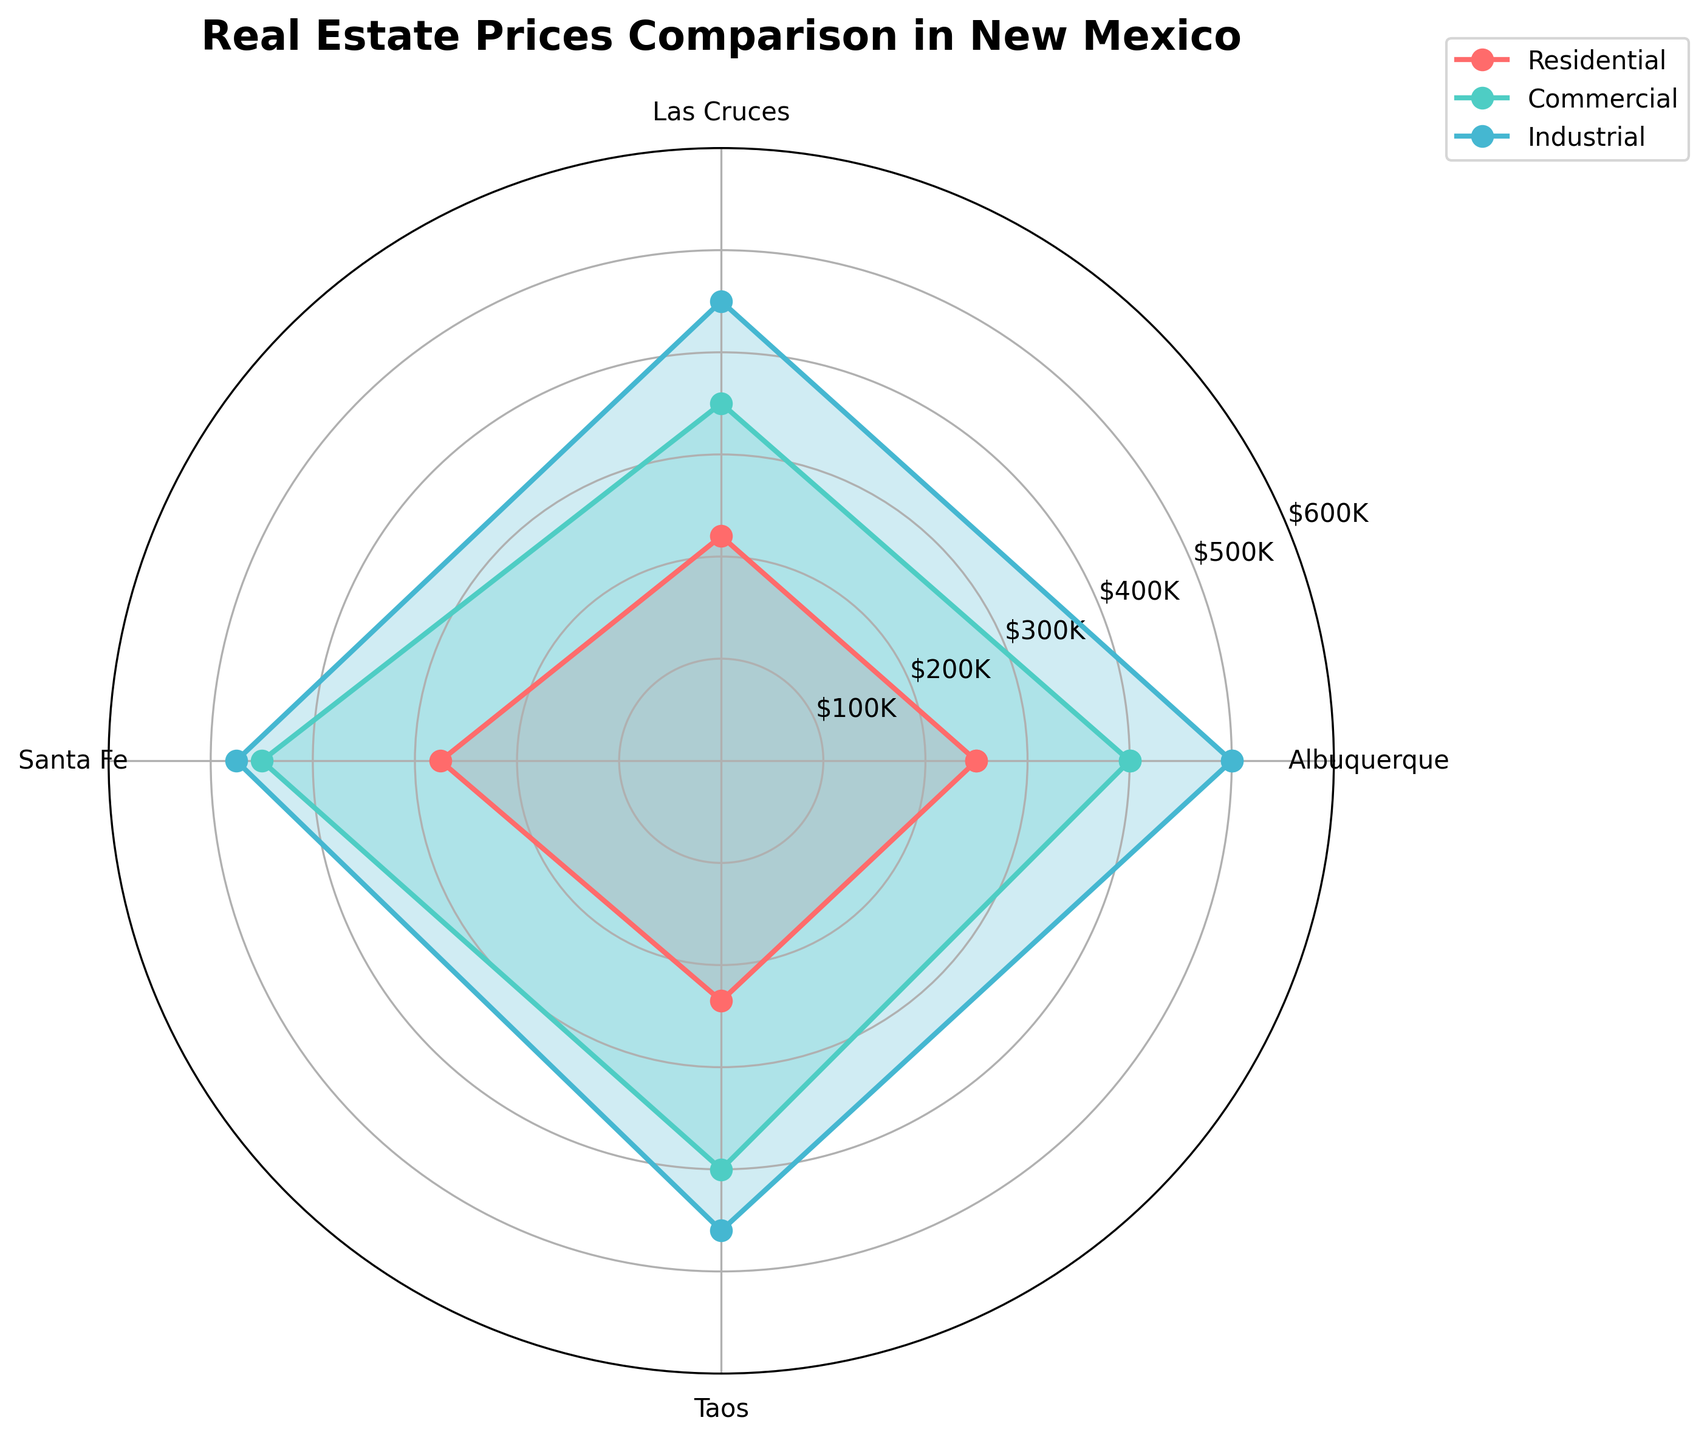What's the title of the chart? The title is displayed at the top of the chart.
Answer: Real Estate Prices Comparison in New Mexico What property type has the highest price in Taos? We look at the Taos value for each property type. Industrial has the highest value.
Answer: Industrial Which property type shows the most significant price difference between Albuquerque and Santa Fe? Calculate the differences: Residential (25,000), Commercial (50,000), Industrial (25,000). The largest difference is for Commercial.
Answer: Commercial What is the average price of commercial properties across all cities? Sum the commercial property prices (400,000 + 350,000 + 450,000 + 400,000) and divide by 4.
Answer: 400,000 Between residential and industrial properties, which type is generally more expensive in all cities combined? Compare the sum of residential prices to the sum of industrial prices: Residential (250,000 + 220,000 + 275,000 + 235,000) & Industrial (500,000 + 450,000 + 475,000 + 460,000). Industrial is higher in all locations.
Answer: Industrial What is the range of residential property prices in the cities shown? Subtract the lowest residential price (220,000) from the highest (275,000).
Answer: 55,000 How does the price trend of commercial properties vary across the cities? By evaluating each city's commercial property prices, we see they are generally highest in Santa Fe, lower in Las Cruces, and lower in Albuquerque and Taos.
Answer: Highest in Santa Fe, lower in Las Cruces, then Albuquerque and Taos Which city has the least variation in property prices across all property types? Calculate the difference between the highest and lowest property prices for each city: Albuquerque (250,000), Las Cruces (230,000), Santa Fe (200,000), Taos (225,000). Santa Fe has the smallest variation.
Answer: Santa Fe In which city do residential properties have the highest relative price compared to other property types? Assess each city by finding the ratio of residential prices to the highest property type price for that city: Albuquerque (50%), Las Cruces (48.8%), Santa Fe (57.9%), Taos (51.1%). Santa Fe has the highest relative residential price.
Answer: Santa Fe 